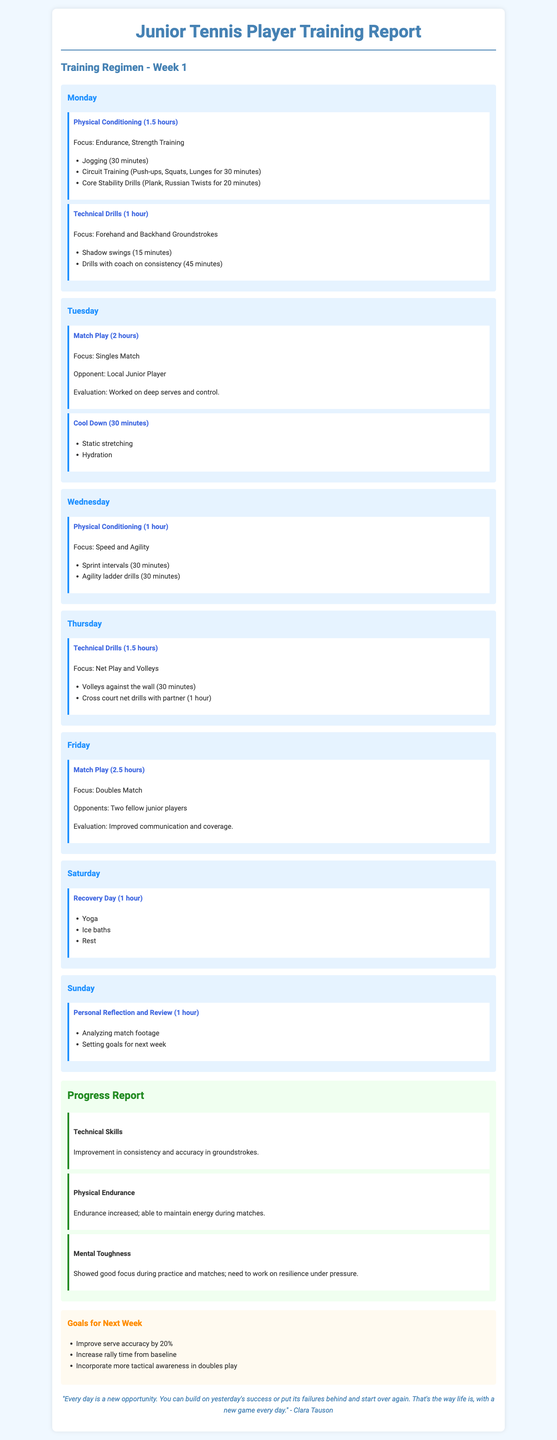What was the focus of physical conditioning on Monday? The physical conditioning on Monday focused on endurance and strength training.
Answer: Endurance, Strength Training How long did the match play session on Tuesday last? The match play session on Tuesday lasted for 2 hours.
Answer: 2 hours Which day included recovery activities? The recovery activities were conducted on Saturday.
Answer: Saturday What is one goal for next week related to serves? One goal is to improve serve accuracy by 20%.
Answer: Improve serve accuracy by 20% What specific improvement was noted in technical skills? The improvement noted in technical skills was in consistency and accuracy in groundstrokes.
Answer: Consistency and accuracy in groundstrokes On which day is personal reflection scheduled? Personal reflection is scheduled on Sunday.
Answer: Sunday How many fellow junior players participated in the doubles match on Friday? Two fellow junior players participated in the doubles match on Friday.
Answer: Two What was a focus area for mental toughness? The focus area for mental toughness involved resilience under pressure.
Answer: Resilience under pressure How long was the cool-down session on Tuesday? The cool-down session on Tuesday lasted for 30 minutes.
Answer: 30 minutes 